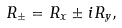Convert formula to latex. <formula><loc_0><loc_0><loc_500><loc_500>R _ { \pm } = R _ { x } \pm i R _ { y } ,</formula> 